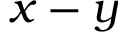<formula> <loc_0><loc_0><loc_500><loc_500>x - y</formula> 